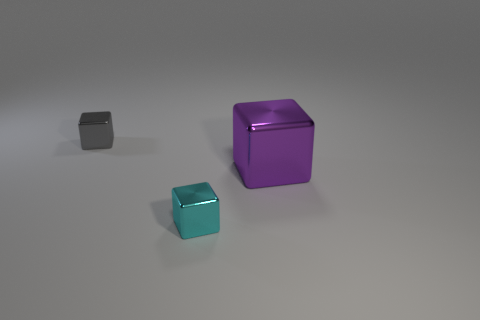What color is the other small cube that is the same material as the gray block?
Make the answer very short. Cyan. Is the cyan metal object the same size as the gray block?
Offer a terse response. Yes. What is the material of the small gray block?
Your answer should be compact. Metal. There is a gray block that is the same size as the cyan shiny thing; what is its material?
Your response must be concise. Metal. Is there a thing that has the same size as the cyan cube?
Your response must be concise. Yes. Are there an equal number of purple cubes behind the purple cube and gray shiny objects behind the small cyan shiny block?
Offer a terse response. No. Is the number of large purple metal objects greater than the number of small brown matte objects?
Offer a very short reply. Yes. What number of shiny things are either large yellow things or tiny gray objects?
Make the answer very short. 1. What material is the thing on the right side of the tiny metallic block that is in front of the small object behind the small cyan shiny object made of?
Offer a terse response. Metal. What color is the tiny thing that is behind the small metallic thing that is to the right of the gray thing?
Your response must be concise. Gray. 